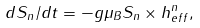<formula> <loc_0><loc_0><loc_500><loc_500>d S _ { n } / d t = - g \mu _ { B } S _ { n } \times h _ { e f f } ^ { n } ,</formula> 